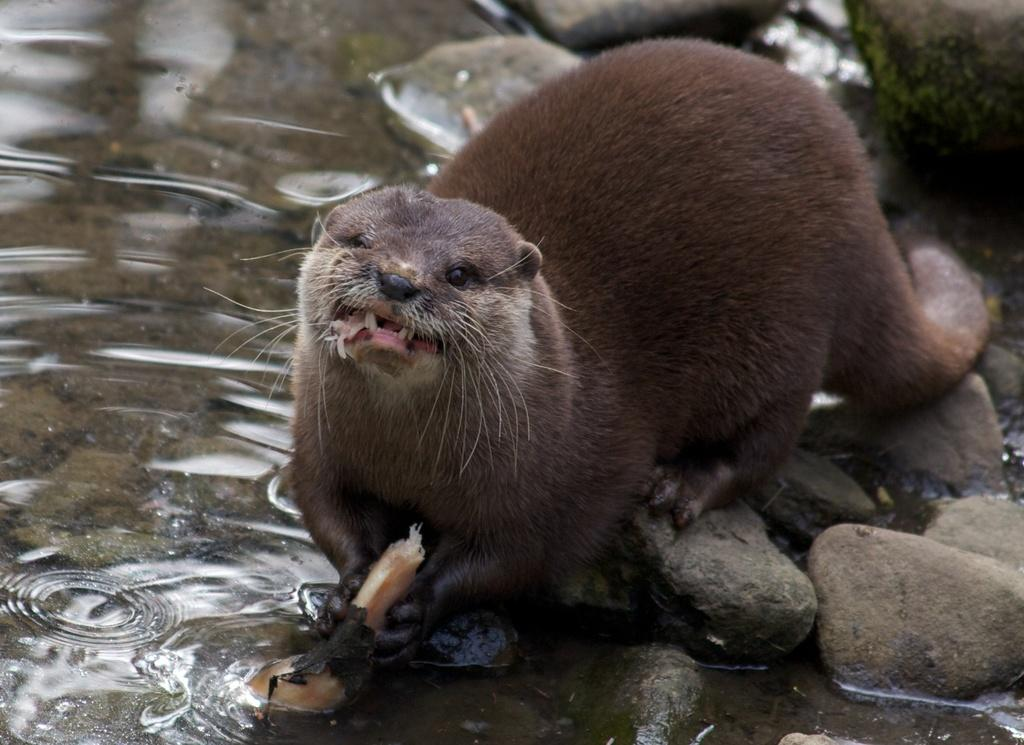What type of animal is in the image? The animal in the image is brown in color. What is the animal standing on? The animal is on stones. What can be seen in the background of the image? There is water visible in the background of the image. What type of crook is the animal using to climb the structure in the image? There is no crook or structure present in the image; the animal is simply standing on stones. 